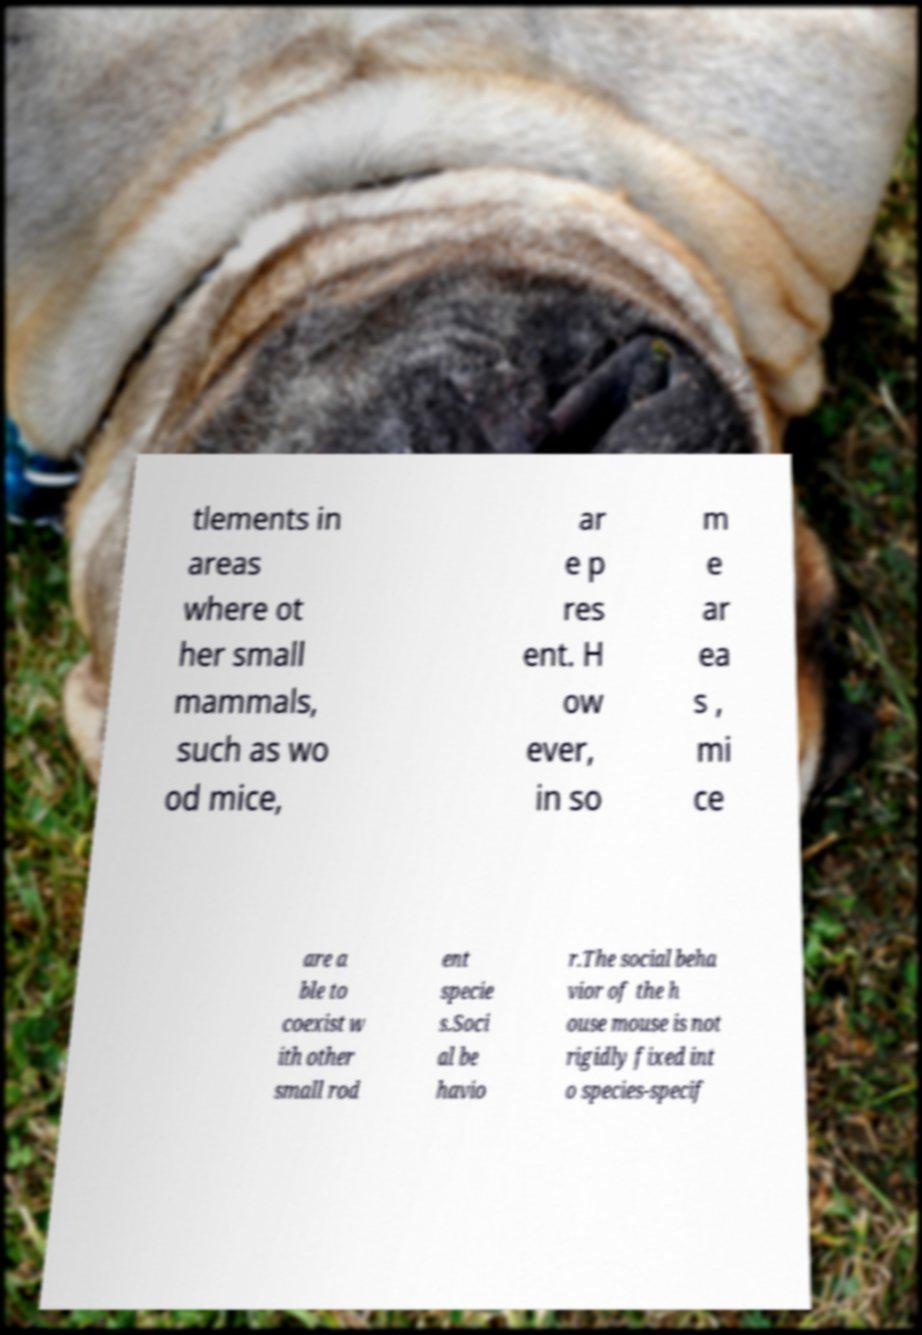Can you read and provide the text displayed in the image?This photo seems to have some interesting text. Can you extract and type it out for me? tlements in areas where ot her small mammals, such as wo od mice, ar e p res ent. H ow ever, in so m e ar ea s , mi ce are a ble to coexist w ith other small rod ent specie s.Soci al be havio r.The social beha vior of the h ouse mouse is not rigidly fixed int o species-specif 